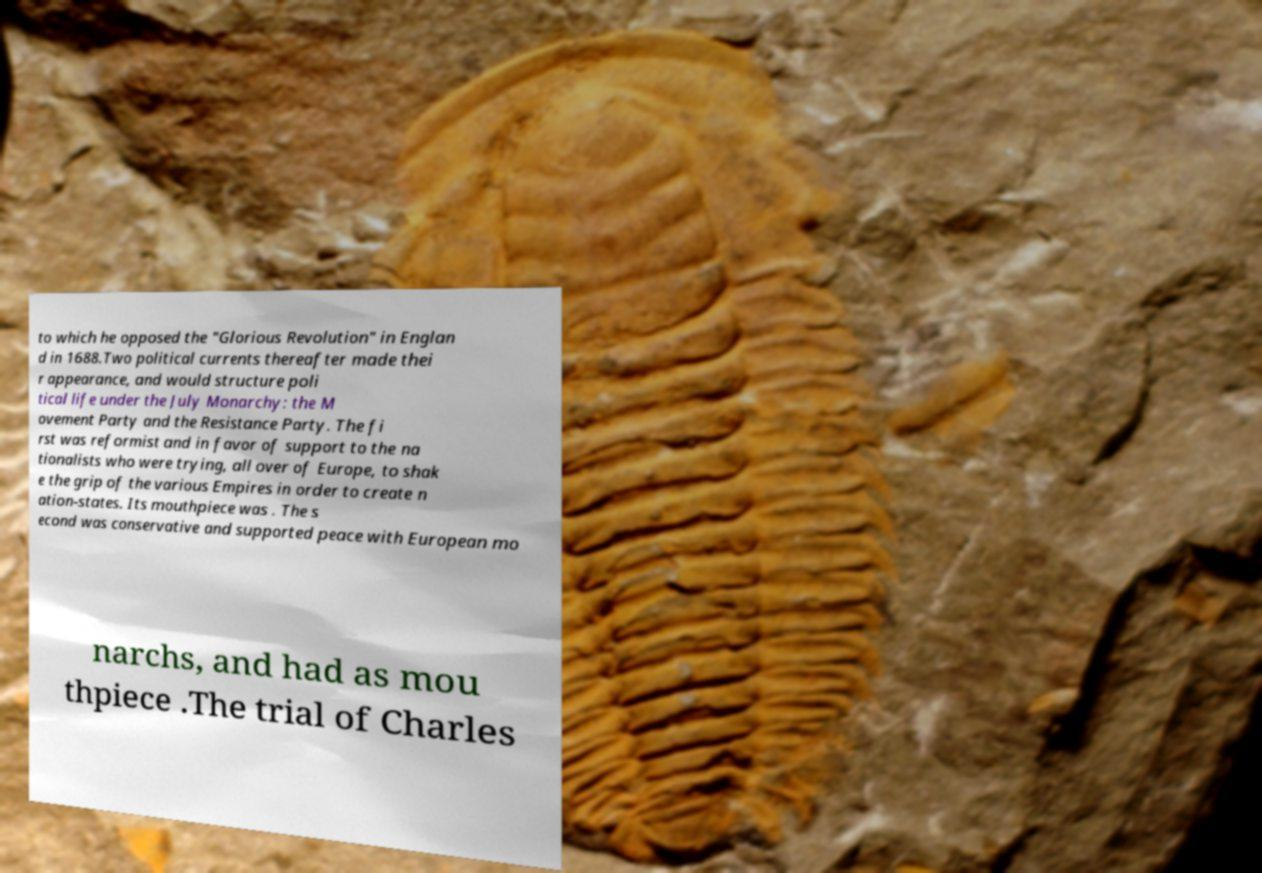Could you assist in decoding the text presented in this image and type it out clearly? to which he opposed the "Glorious Revolution" in Englan d in 1688.Two political currents thereafter made thei r appearance, and would structure poli tical life under the July Monarchy: the M ovement Party and the Resistance Party. The fi rst was reformist and in favor of support to the na tionalists who were trying, all over of Europe, to shak e the grip of the various Empires in order to create n ation-states. Its mouthpiece was . The s econd was conservative and supported peace with European mo narchs, and had as mou thpiece .The trial of Charles 